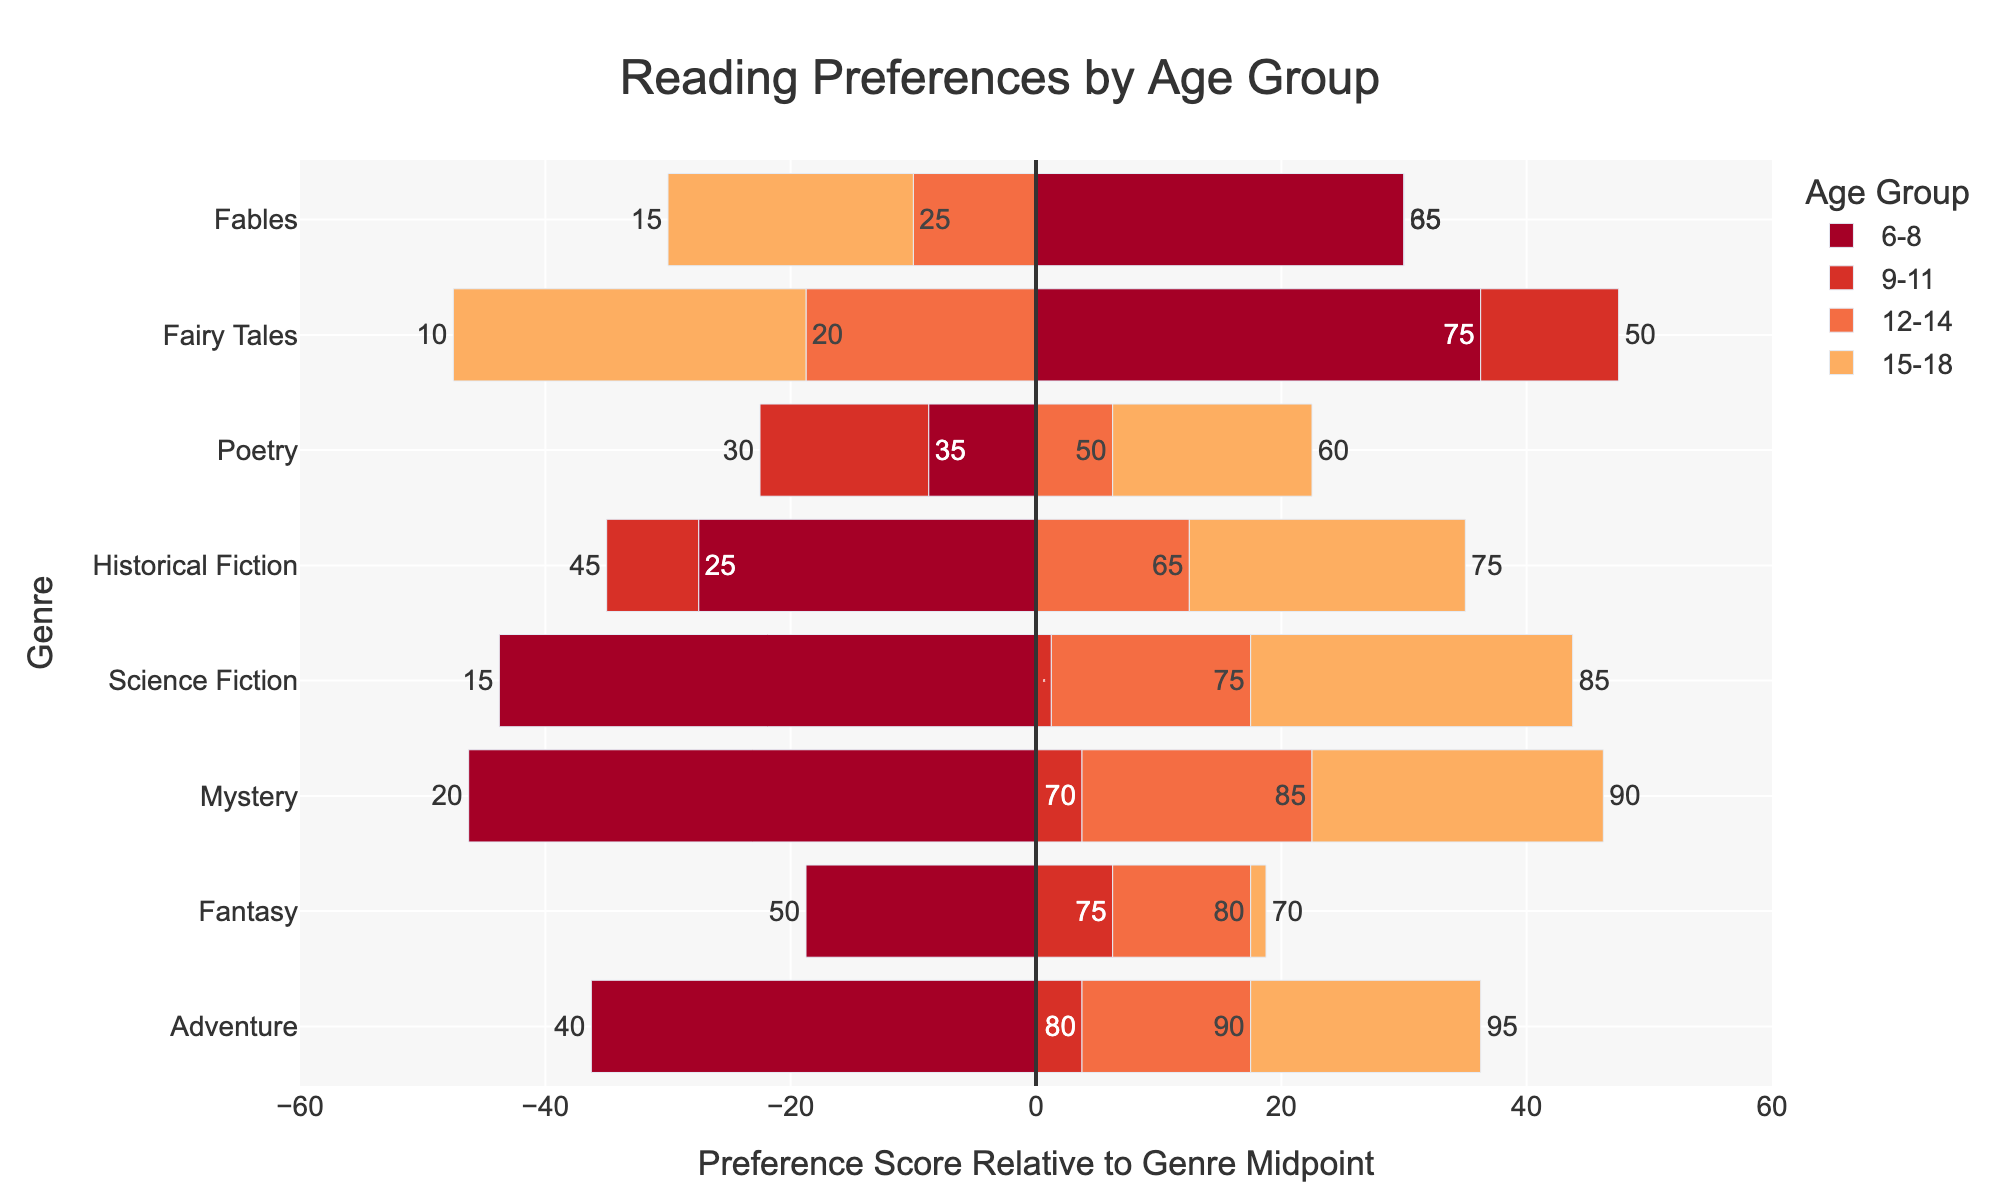Which genre do 9-11 year-olds prefer the most? Look at the bar lengths for the 9-11 age group and compare them. The longest bar represents the most preferred genre.
Answer: Adventure How does the preference for Fantasy change from age group 6-8 to 15-18? Observe the position and length of the bars for Fantasy across different age groups. Subtract the 6-8 preference score from the 15-18 preference score.
Answer: Drops by 20 points Which genre shows the greatest increase in preference from age group 6-8 to 9-11? Compare the preference scores for each genre between the 6-8 and 9-11 age groups and identify the largest increase.
Answer: Adventure Do 12-14 year-olds and 15-18 year-olds have similar preferences for Mystery? Compare the lengths and positions of the Mystery bars for the 12-14 and 15-18 age groups.
Answer: Yes, they are similar Which age group has the least preference for Fairy Tales? Identify the smallest bar length among the age groups for the Fairy Tales genre.
Answer: 15-18 Which genres have a preference score above 70 for the 12-14 age group? Check the bars for the 12-14 age group and identify genres with lengths extending beyond the 70 mark.
Answer: Adventure, Mystery, Fantasy, Science Fiction Is Poetry more preferred by 15-18 year-olds or 6-8 year-olds? Compare the lengths of the Poetry bars between the 15-18 and 6-8 age groups.
Answer: 15-18 year-olds How does the preference for Adventure change across all age groups? Note the position and length of the Adventure bars for each age group and see the trend.
Answer: Increases with age Which genre has the most balanced preference across all age groups? Look for the genre where the bars are nearly equal in length across all age groups.
Answer: Historical Fiction 